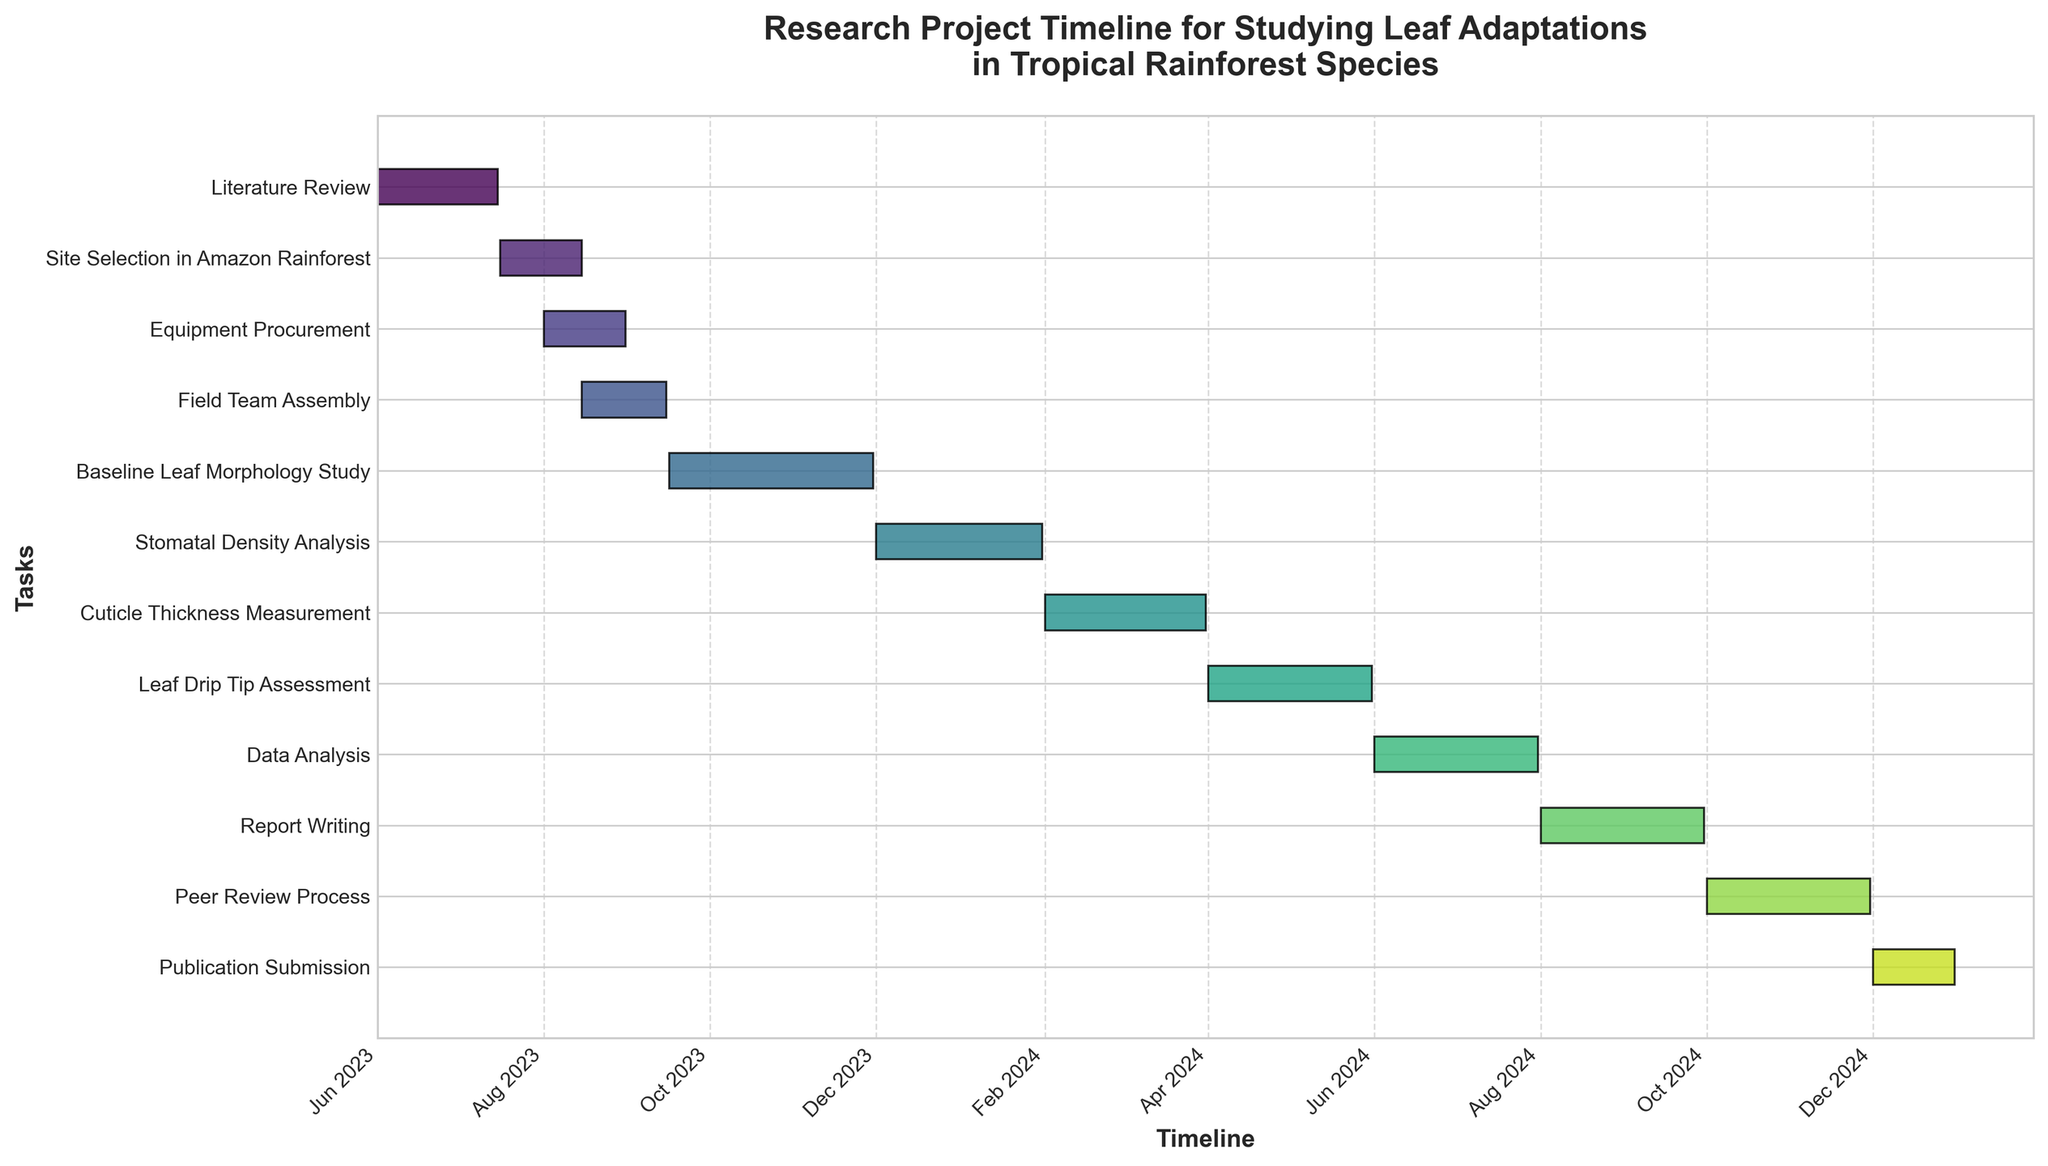What's the title of the figure? The title is typically located at the top of a Gantt Chart and provides a summary of what the chart represents. In this case, the title is given in the code as 'Research Project Timeline for Studying Leaf Adaptations in Tropical Rainforest Species.'
Answer: Research Project Timeline for Studying Leaf Adaptations in Tropical Rainforest Species Which task has the longest duration? To find the task with the longest duration, compare the length of the bars representing each task. The task with the longest bar is 'Baseline Leaf Morphology Study' from 2023-09-16 to 2023-11-30.
Answer: Baseline Leaf Morphology Study When does the 'Report Writing' task start and end? Locate the 'Report Writing' task from the y-axis labels and refer to the x-axis for corresponding start and end dates. It starts on 2024-08-01 and ends on 2024-09-30.
Answer: 2024-08-01 to 2024-09-30 How much overlap is there between 'Equipment Procurement' and 'Field Team Assembly'? Identify both tasks on the y-axis and check their timelines on the x-axis. 'Equipment Procurement' runs from 2023-08-01 to 2023-08-31, and 'Field Team Assembly' from 2023-08-15 to 2023-09-15. The overlap is from 2023-08-15 to 2023-08-31.
Answer: 16 days How many tasks start in August 2023? Look at the timeline on the x-axis for August 2023 and count the tasks that begin within this month. 'Site Selection in Amazon Rainforest,' 'Equipment Procurement,' and 'Field Team Assembly' all start in August 2023.
Answer: 3 tasks How does the duration of 'Stomatal Density Analysis' compare to 'Cuticle Thickness Measurement'? Check the length of the bars for both tasks. 'Stomatal Density Analysis' runs from 2023-12-01 to 2024-01-31 (61 days), and 'Cuticle Thickness Measurement' from 2024-02-01 to 2024-03-31 (60 days).
Answer: Almost the same duration Which tasks are concurrent with 'Baseline Leaf Morphology Study'? Identify the duration of 'Baseline Leaf Morphology Study,' then check other tasks' bars for overlap. 'Field Team Assembly' overlaps partially at the beginning.
Answer: Field Team Assembly What is the total duration for all tasks combined? Sum up the individual durations of all tasks. Calculate the duration for each task in days and add them together.
Answer: 1.5 years Which task follows immediately after 'Peer Review Process'? Look at the next task that starts right after the end date of 'Peer Review Process,' which ends on 2024-11-30. 'Publication Submission' starts immediately after.
Answer: Publication Submission 